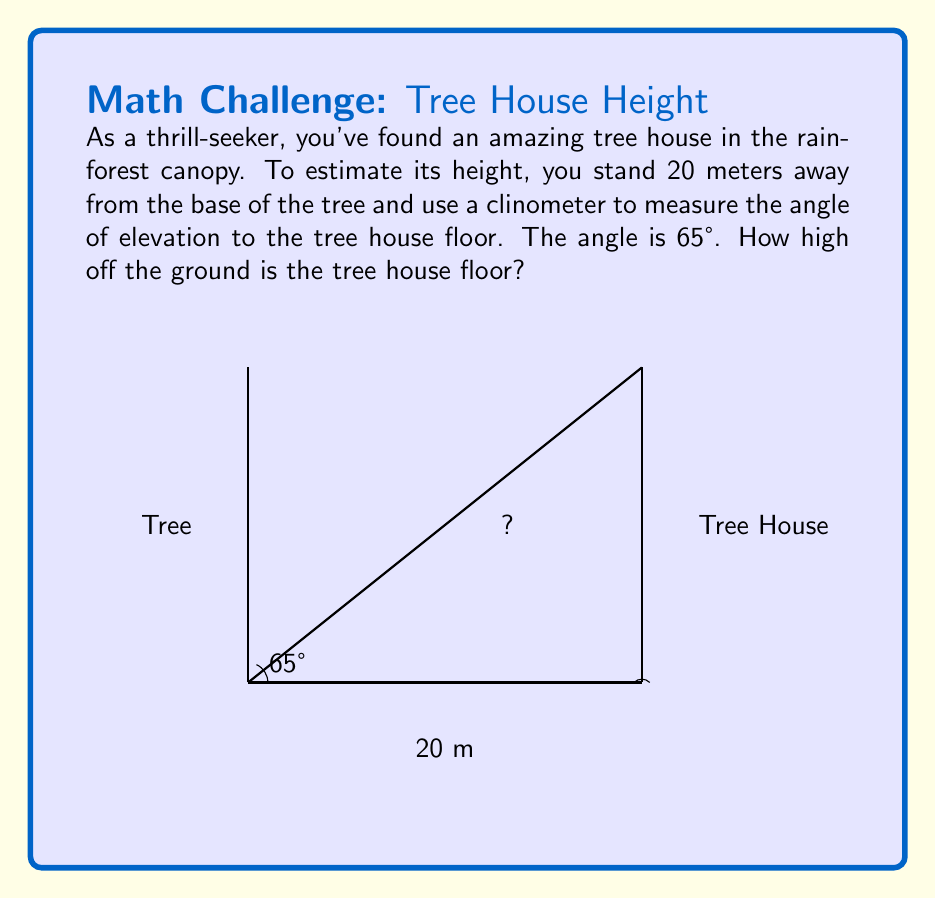Provide a solution to this math problem. Let's solve this problem step by step using trigonometry:

1) In this scenario, we have a right-angled triangle. The tree house height is the opposite side, the distance from us to the tree is the adjacent side, and the line of sight to the tree house is the hypotenuse.

2) We know:
   - The adjacent side (distance to tree) = 20 meters
   - The angle of elevation = 65°

3) We need to find the opposite side (height of the tree house).

4) The trigonometric ratio that relates the opposite side to the adjacent side is the tangent (tan).

5) The formula is:
   $$ \tan(\theta) = \frac{\text{opposite}}{\text{adjacent}} $$

6) Substituting our known values:
   $$ \tan(65°) = \frac{\text{height}}{20} $$

7) To solve for height, we multiply both sides by 20:
   $$ 20 \cdot \tan(65°) = \text{height} $$

8) Using a calculator (or trigonometric tables):
   $$ \text{height} = 20 \cdot \tan(65°) \approx 20 \cdot 2.1445 \approx 42.89 \text{ meters} $$

Therefore, the tree house floor is approximately 42.89 meters above the ground.
Answer: 42.89 meters 